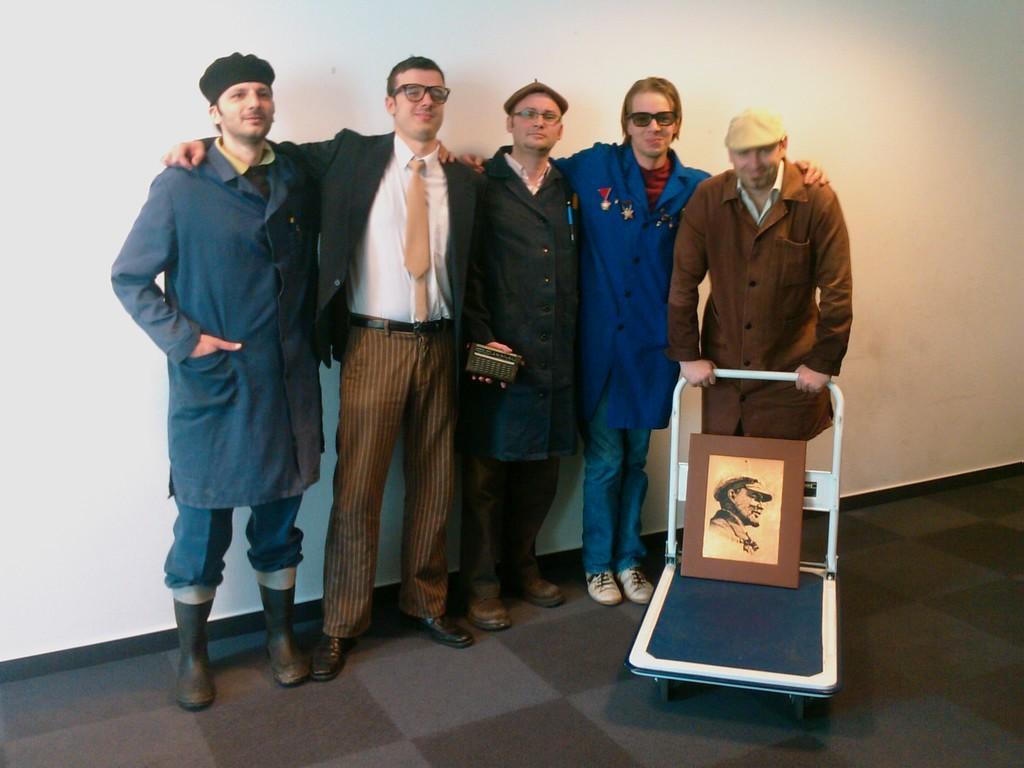Could you give a brief overview of what you see in this image? In the middle of the image few people are standing and smiling. Behind them there is a wall. Bottom right side of the image a person is holding a cart, on the cart there is a frame. 